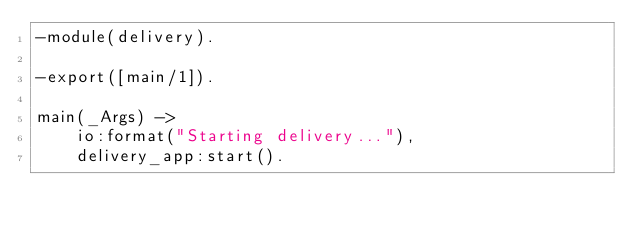<code> <loc_0><loc_0><loc_500><loc_500><_Erlang_>-module(delivery).

-export([main/1]).

main(_Args) ->
    io:format("Starting delivery..."),
    delivery_app:start().
</code> 